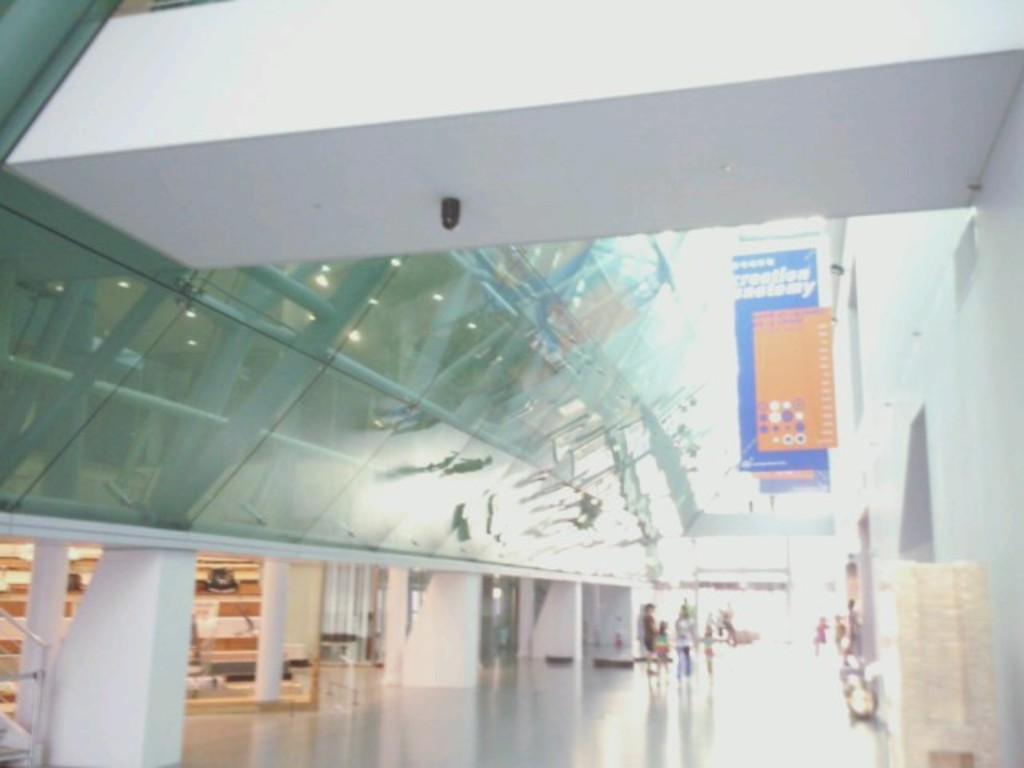Describe this image in one or two sentences. This picture shows the inner view of a building. There are some people walking, one glass wall, some objects attached to the ceiling, some banners with text, some objects attached to the wall, some pillars and some objects on the floor. 